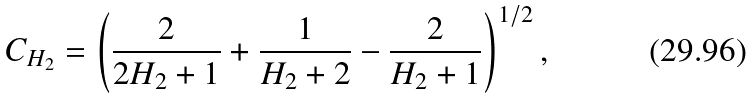Convert formula to latex. <formula><loc_0><loc_0><loc_500><loc_500>C _ { H _ { 2 } } = \left ( \frac { 2 } { 2 H _ { 2 } + 1 } + \frac { 1 } { H _ { 2 } + 2 } - \frac { 2 } { H _ { 2 } + 1 } \right ) ^ { 1 / 2 } ,</formula> 